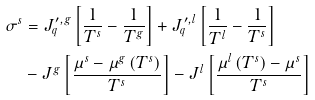Convert formula to latex. <formula><loc_0><loc_0><loc_500><loc_500>\sigma ^ { s } & = J _ { q } ^ { \prime , g } \left [ \frac { 1 } { T ^ { s } } - \frac { 1 } { T ^ { g } } \right ] + J _ { q } ^ { \prime , l } \left [ \frac { 1 } { T ^ { l } } - \frac { 1 } { T ^ { s } } \right ] \\ & - J ^ { g } \left [ \frac { \mu ^ { s } - \mu ^ { g } \left ( T ^ { s } \right ) } { T ^ { s } } \right ] - J ^ { l } \left [ \frac { \mu ^ { l } \left ( T ^ { s } \right ) - \mu ^ { s } } { T ^ { s } } \right ]</formula> 